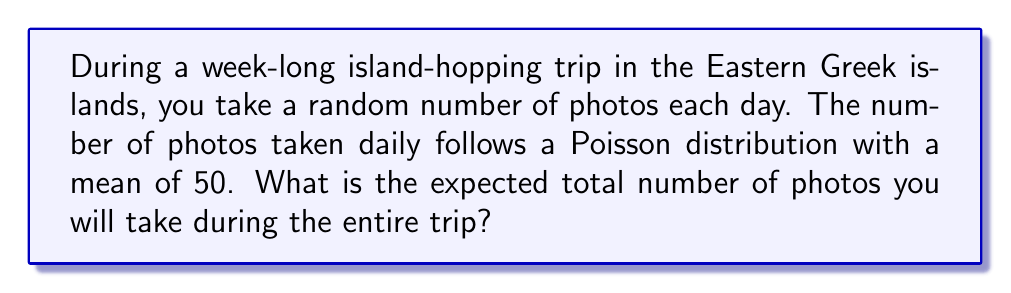What is the answer to this math problem? Let's approach this step-by-step:

1) First, we need to understand what we're given:
   - The trip lasts 7 days
   - The number of photos taken each day follows a Poisson distribution
   - The mean (λ) of this Poisson distribution is 50 photos per day

2) In a Poisson distribution, the expected value (mean) is equal to λ. So, on average, you take 50 photos per day.

3) Let $X_i$ be the random variable representing the number of photos taken on day $i$. Then:

   $E[X_i] = 50$ for each $i$ from 1 to 7

4) Let $Y$ be the total number of photos taken over the 7 days. Then:

   $Y = X_1 + X_2 + X_3 + X_4 + X_5 + X_6 + X_7$

5) We need to find $E[Y]$. Using the linearity of expectation:

   $E[Y] = E[X_1 + X_2 + X_3 + X_4 + X_5 + X_6 + X_7]$
   
   $E[Y] = E[X_1] + E[X_2] + E[X_3] + E[X_4] + E[X_5] + E[X_6] + E[X_7]$

6) Since $E[X_i] = 50$ for all $i$:

   $E[Y] = 50 + 50 + 50 + 50 + 50 + 50 + 50 = 7 * 50 = 350$

Therefore, the expected total number of photos taken during the 7-day trip is 350.
Answer: 350 photos 